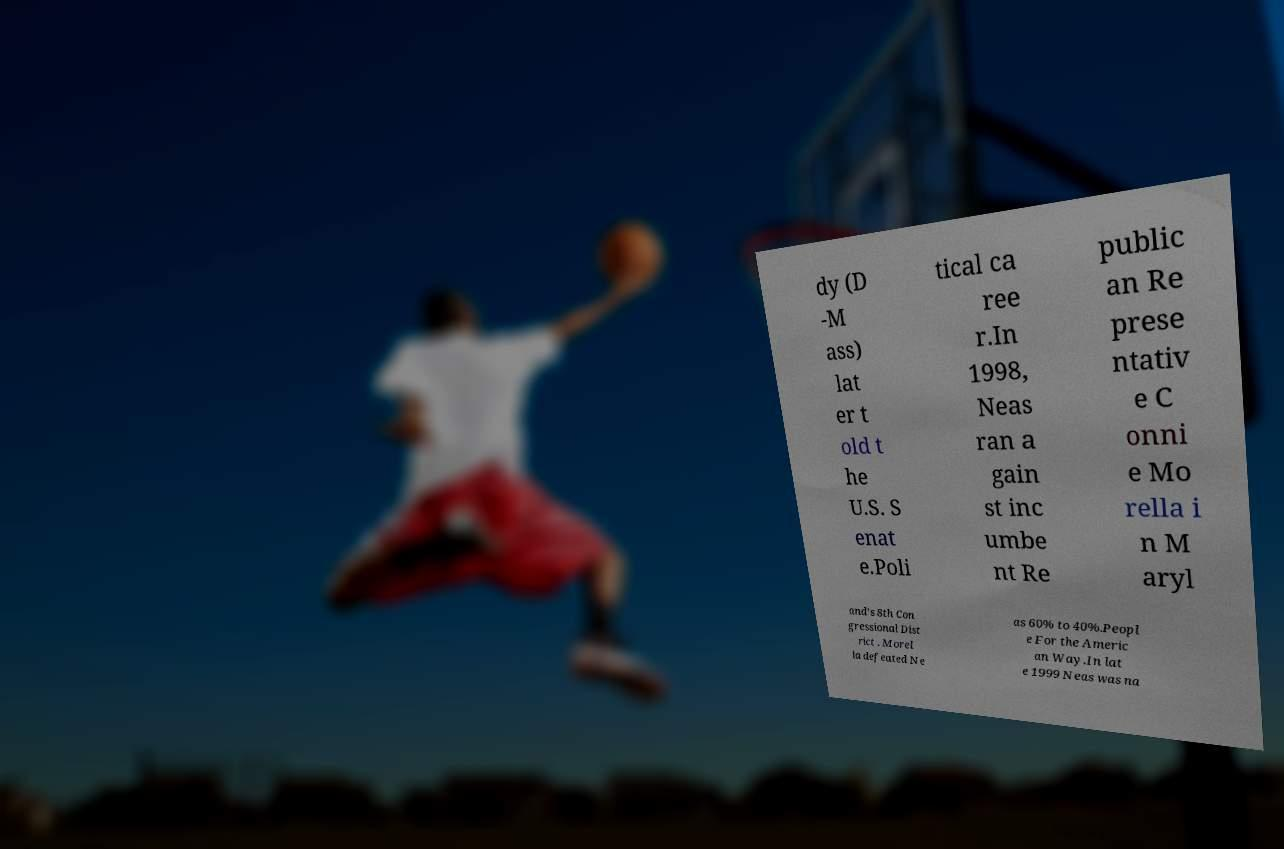Can you read and provide the text displayed in the image?This photo seems to have some interesting text. Can you extract and type it out for me? dy (D -M ass) lat er t old t he U.S. S enat e.Poli tical ca ree r.In 1998, Neas ran a gain st inc umbe nt Re public an Re prese ntativ e C onni e Mo rella i n M aryl and's 8th Con gressional Dist rict . Morel la defeated Ne as 60% to 40%.Peopl e For the Americ an Way.In lat e 1999 Neas was na 